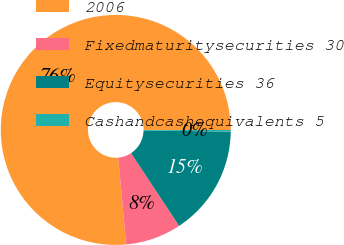Convert chart. <chart><loc_0><loc_0><loc_500><loc_500><pie_chart><fcel>2006<fcel>Fixedmaturitysecurities 30<fcel>Equitysecurities 36<fcel>Cashandcashequivalents 5<nl><fcel>76.45%<fcel>7.85%<fcel>15.47%<fcel>0.23%<nl></chart> 